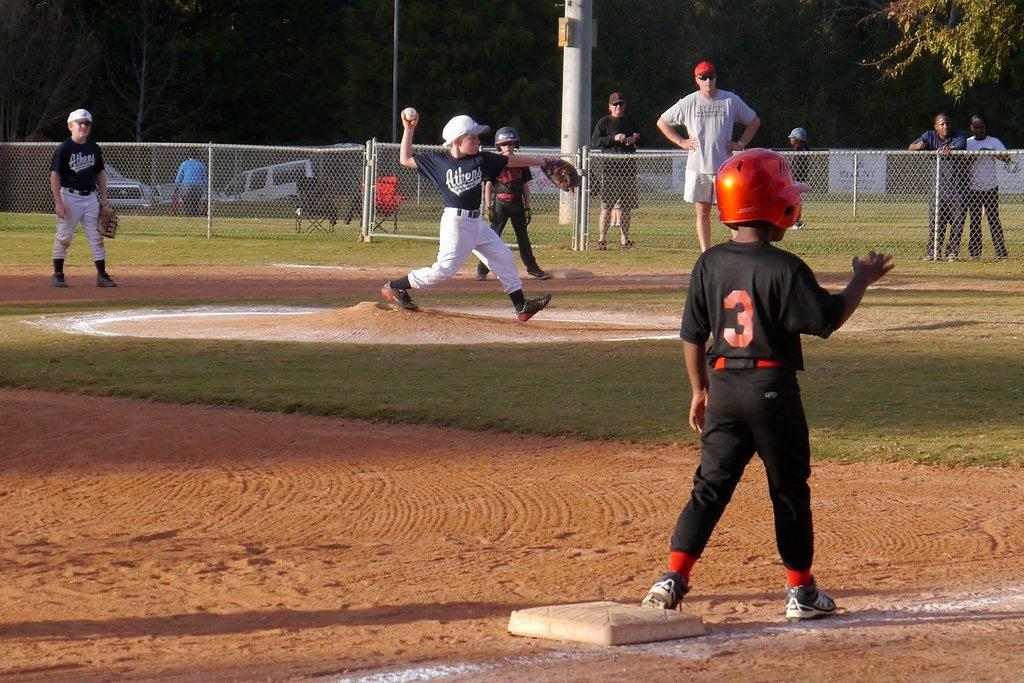<image>
Summarize the visual content of the image. A boy wearing Athens jersey is throwing the baseball. 